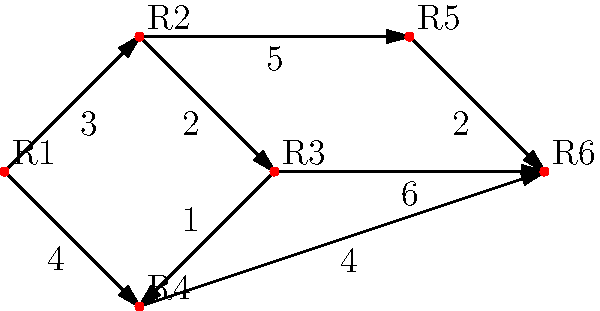In the backstage area of the Bolshoi Theatre, six dressing rooms (R1 to R6) are connected by corridors. The graph shows the layout, with edges representing corridors and weights indicating the time (in minutes) to walk between rooms. What is the shortest time required to go from dressing room R1 to R6? To find the shortest path from R1 (vertex 0) to R6 (vertex 5), we can use Dijkstra's algorithm:

1. Initialize distances: R1(0) = 0, all others = $\infty$
2. Visit R1, update neighbors:
   R2: 0 + 3 = 3
   R4: 0 + 4 = 4
3. Visit R2 (closest unvisited), update neighbors:
   R3: 3 + 2 = 5
   R5: 3 + 5 = 8
4. Visit R4, update neighbors:
   R6: 4 + 4 = 8
5. Visit R3, update neighbors:
   R6: 5 + 6 = 11 (not shorter)
6. Visit R5, update neighbors:
   R6: 8 + 2 = 10 (shorter than current R6)

The shortest path is R1 -> R2 -> R5 -> R6, with a total time of 10 minutes.
Answer: 10 minutes 